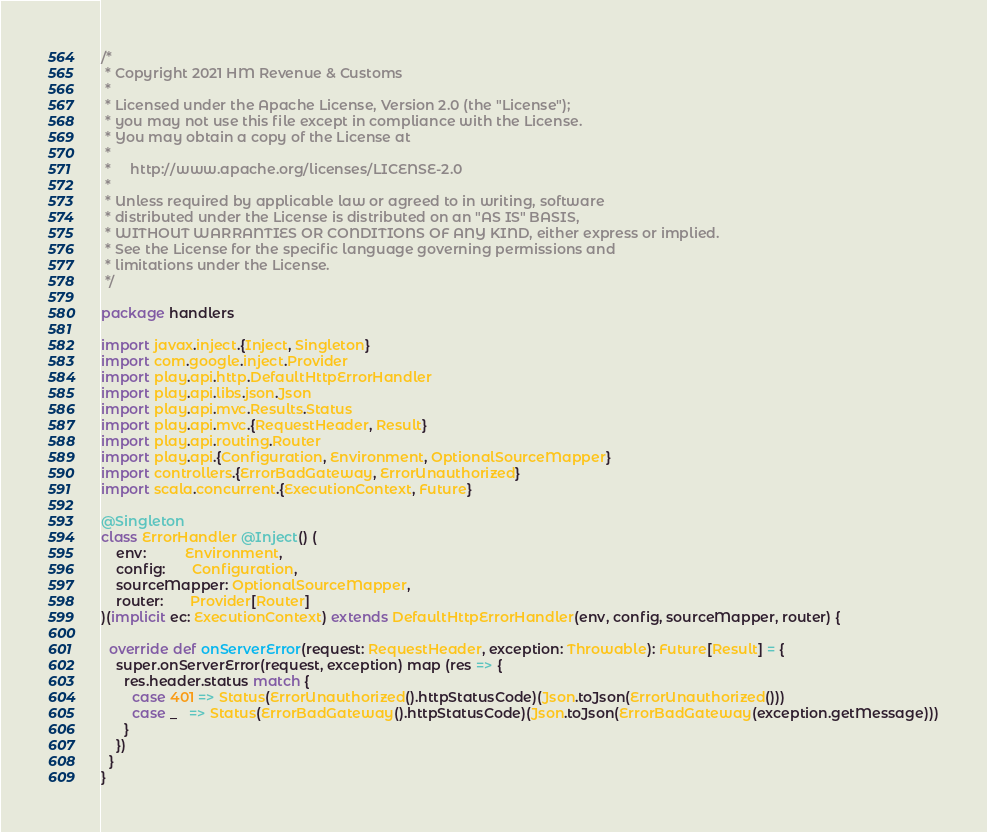Convert code to text. <code><loc_0><loc_0><loc_500><loc_500><_Scala_>/*
 * Copyright 2021 HM Revenue & Customs
 *
 * Licensed under the Apache License, Version 2.0 (the "License");
 * you may not use this file except in compliance with the License.
 * You may obtain a copy of the License at
 *
 *     http://www.apache.org/licenses/LICENSE-2.0
 *
 * Unless required by applicable law or agreed to in writing, software
 * distributed under the License is distributed on an "AS IS" BASIS,
 * WITHOUT WARRANTIES OR CONDITIONS OF ANY KIND, either express or implied.
 * See the License for the specific language governing permissions and
 * limitations under the License.
 */

package handlers

import javax.inject.{Inject, Singleton}
import com.google.inject.Provider
import play.api.http.DefaultHttpErrorHandler
import play.api.libs.json.Json
import play.api.mvc.Results.Status
import play.api.mvc.{RequestHeader, Result}
import play.api.routing.Router
import play.api.{Configuration, Environment, OptionalSourceMapper}
import controllers.{ErrorBadGateway, ErrorUnauthorized}
import scala.concurrent.{ExecutionContext, Future}

@Singleton
class ErrorHandler @Inject() (
    env:          Environment,
    config:       Configuration,
    sourceMapper: OptionalSourceMapper,
    router:       Provider[Router]
)(implicit ec: ExecutionContext) extends DefaultHttpErrorHandler(env, config, sourceMapper, router) {

  override def onServerError(request: RequestHeader, exception: Throwable): Future[Result] = {
    super.onServerError(request, exception) map (res => {
      res.header.status match {
        case 401 => Status(ErrorUnauthorized().httpStatusCode)(Json.toJson(ErrorUnauthorized()))
        case _   => Status(ErrorBadGateway().httpStatusCode)(Json.toJson(ErrorBadGateway(exception.getMessage)))
      }
    })
  }
}
</code> 